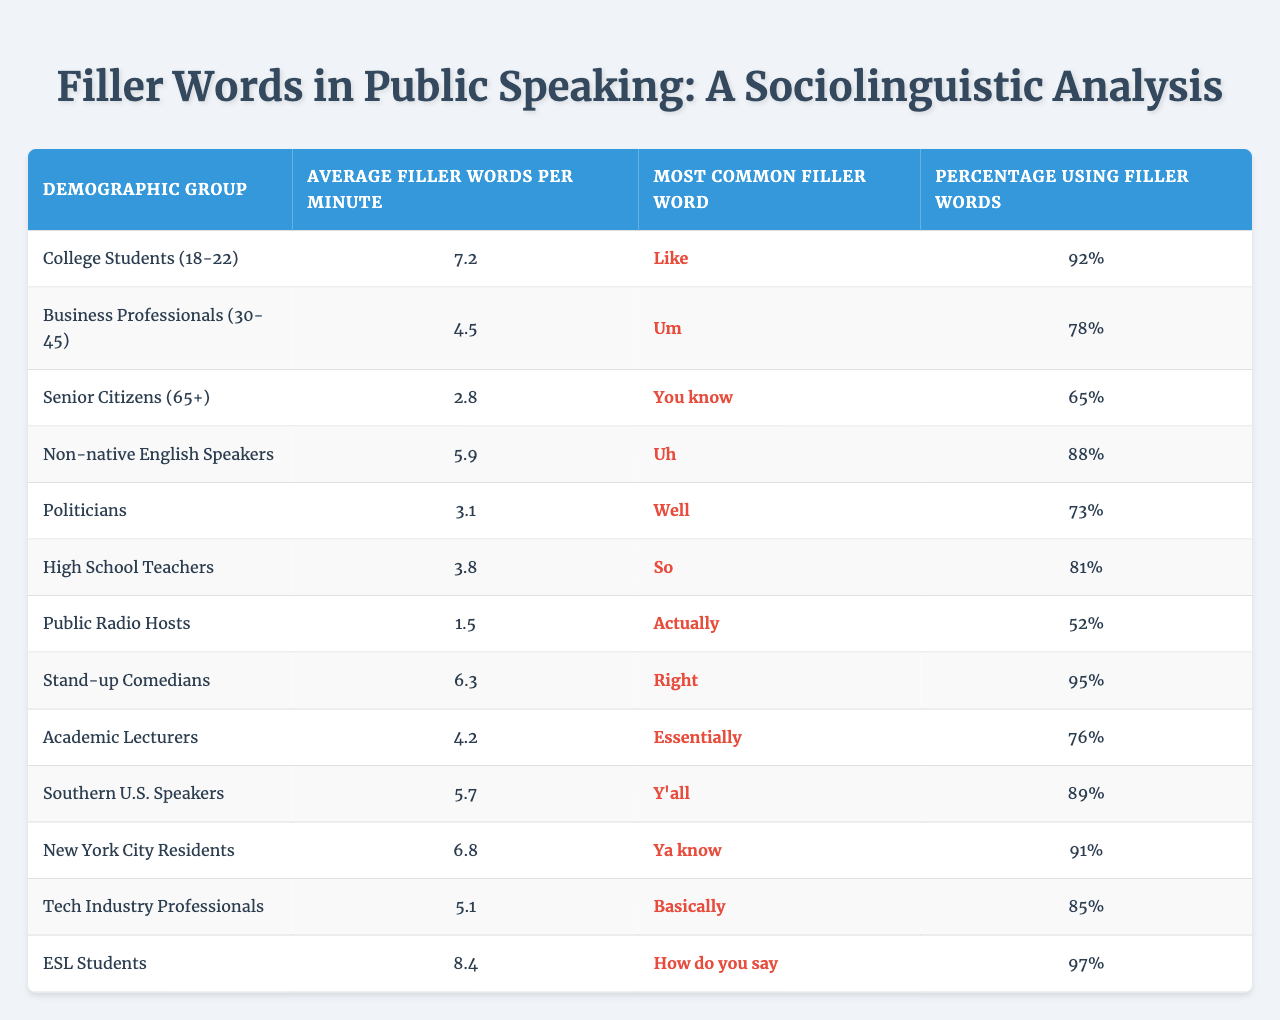What is the average filler words per minute for college students? From the table, the average filler words per minute for college students (18-22) is directly listed as 7.2.
Answer: 7.2 Which demographic group has the highest percentage using filler words? The table shows that ESL students have the highest percentage of 97% using filler words.
Answer: ESL Students What is the most common filler word used by senior citizens? According to the table, the most common filler word for senior citizens (65+) is "You know."
Answer: You know How many filler words per minute do public radio hosts use on average? The table indicates that public radio hosts use an average of 1.5 filler words per minute.
Answer: 1.5 What is the difference in average filler words per minute between college students and business professionals? The average for college students is 7.2, and for business professionals, it is 4.5. The difference is calculated as 7.2 - 4.5 = 2.7.
Answer: 2.7 Are stand-up comedians more likely to use filler words compared to senior citizens? Stand-up comedians have an average of 6.3 filler words per minute compared to senior citizens who have 2.8, indicating that comedians are more likely to use filler words.
Answer: Yes Which group has the lowest average filler words per minute and what is that number? The table shows that public radio hosts have the lowest average at 1.5 filler words per minute.
Answer: 1.5 How many demographic groups have a percentage of filler words usage above 80%? By reviewing the table, the groups with above 80% are college students, non-native English speakers, stand-up comedians, southern U.S. speakers, and ESL students, totaling five groups.
Answer: 5 Is "Uh" more common than "Um" among public speaking groups? From the table, "Uh" is used by non-native English speakers as their most common filler word while "Um" is most common among business professionals. The percentages indicate that "Uh" is more common (88% vs. 78%).
Answer: Yes Calculate the average of the average filler words per minute for all groups listed in the table. Adding up the average filler words: (7.2 + 4.5 + 2.8 + 5.9 + 3.1 + 3.8 + 1.5 + 6.3 + 4.2 + 5.7 + 6.8 + 5.1 + 8.4) gives a total of 64.4. There are 13 groups, thus the average is 64.4 / 13 = 4.96, rounded to two decimal places.
Answer: 4.96 